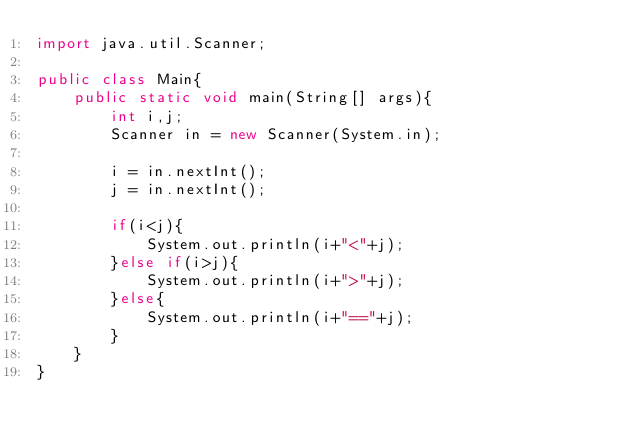<code> <loc_0><loc_0><loc_500><loc_500><_Java_>import java.util.Scanner;

public class Main{
	public static void main(String[] args){
		int i,j;
		Scanner in = new Scanner(System.in);
		
		i = in.nextInt();
		j = in.nextInt();
		
		if(i<j){
			System.out.println(i+"<"+j);
		}else if(i>j){
			System.out.println(i+">"+j);
		}else{
			System.out.println(i+"=="+j);
		}
	}
}</code> 